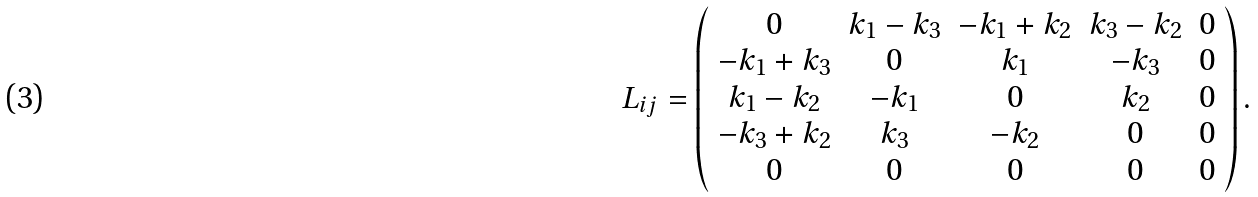Convert formula to latex. <formula><loc_0><loc_0><loc_500><loc_500>L _ { i j } = \left ( \begin{array} { c c c c c } 0 & k _ { 1 } - k _ { 3 } & - k _ { 1 } + k _ { 2 } & k _ { 3 } - k _ { 2 } & 0 \\ - k _ { 1 } + k _ { 3 } & 0 & k _ { 1 } & - k _ { 3 } & 0 \\ k _ { 1 } - k _ { 2 } & - k _ { 1 } & 0 & k _ { 2 } & 0 \\ - k _ { 3 } + k _ { 2 } & k _ { 3 } & - k _ { 2 } & 0 & 0 \\ 0 & 0 & 0 & 0 & 0 \end{array} \right ) .</formula> 